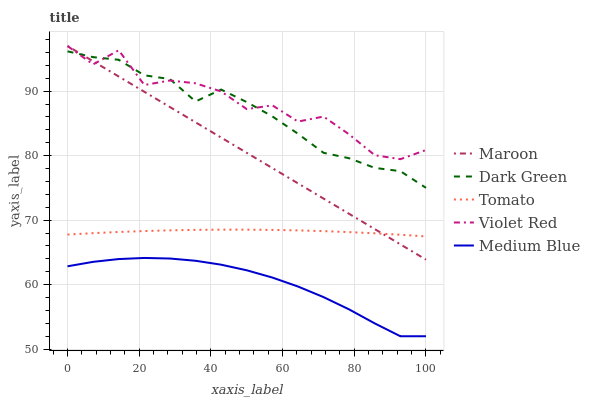Does Medium Blue have the minimum area under the curve?
Answer yes or no. Yes. Does Violet Red have the maximum area under the curve?
Answer yes or no. Yes. Does Violet Red have the minimum area under the curve?
Answer yes or no. No. Does Medium Blue have the maximum area under the curve?
Answer yes or no. No. Is Maroon the smoothest?
Answer yes or no. Yes. Is Violet Red the roughest?
Answer yes or no. Yes. Is Medium Blue the smoothest?
Answer yes or no. No. Is Medium Blue the roughest?
Answer yes or no. No. Does Medium Blue have the lowest value?
Answer yes or no. Yes. Does Violet Red have the lowest value?
Answer yes or no. No. Does Maroon have the highest value?
Answer yes or no. Yes. Does Medium Blue have the highest value?
Answer yes or no. No. Is Tomato less than Dark Green?
Answer yes or no. Yes. Is Maroon greater than Medium Blue?
Answer yes or no. Yes. Does Violet Red intersect Dark Green?
Answer yes or no. Yes. Is Violet Red less than Dark Green?
Answer yes or no. No. Is Violet Red greater than Dark Green?
Answer yes or no. No. Does Tomato intersect Dark Green?
Answer yes or no. No. 